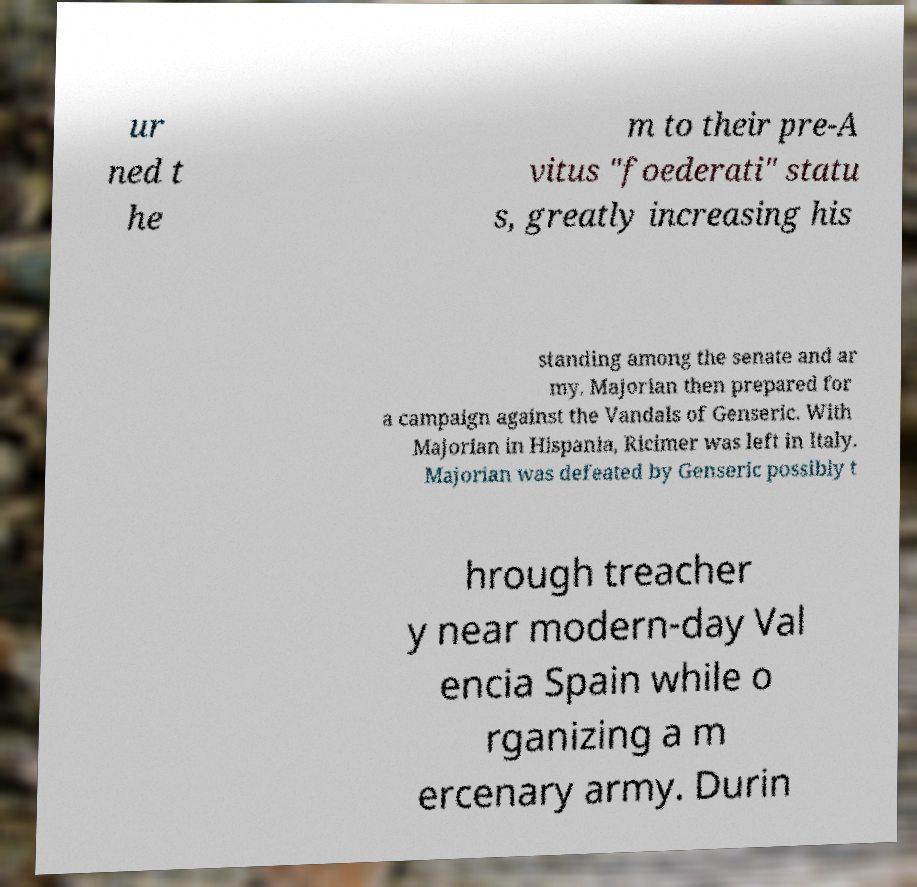For documentation purposes, I need the text within this image transcribed. Could you provide that? ur ned t he m to their pre-A vitus "foederati" statu s, greatly increasing his standing among the senate and ar my. Majorian then prepared for a campaign against the Vandals of Genseric. With Majorian in Hispania, Ricimer was left in Italy. Majorian was defeated by Genseric possibly t hrough treacher y near modern-day Val encia Spain while o rganizing a m ercenary army. Durin 